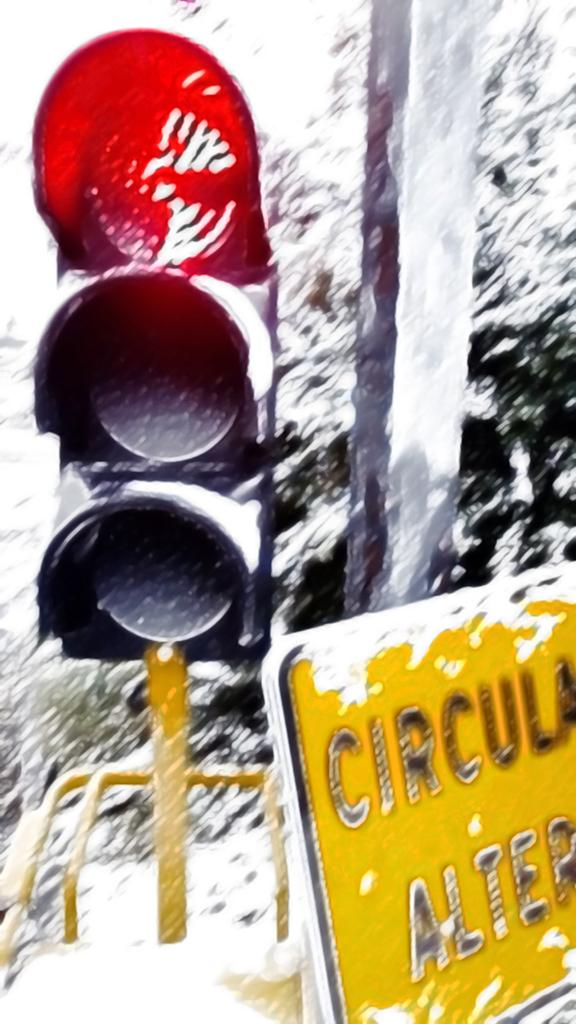<image>
Provide a brief description of the given image. A snow-covered traffic light is above a yellow sign that says Circular Alter. 